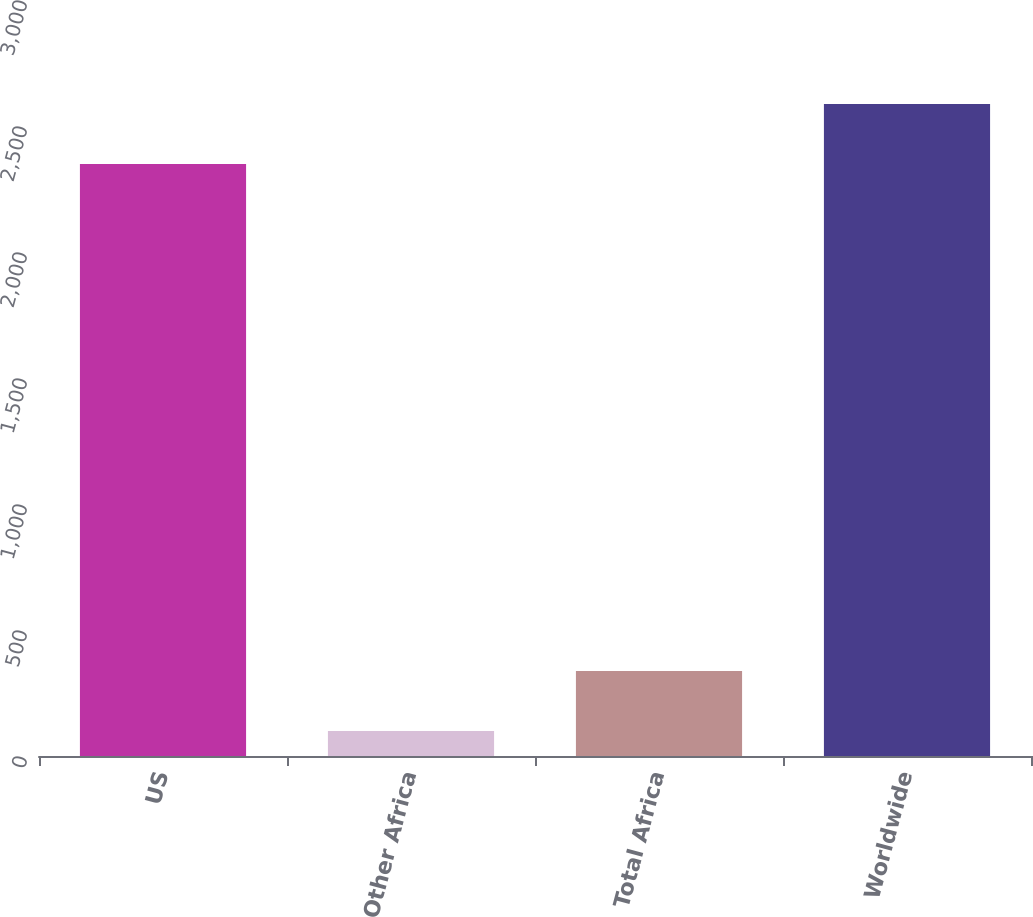Convert chart. <chart><loc_0><loc_0><loc_500><loc_500><bar_chart><fcel>US<fcel>Other Africa<fcel>Total Africa<fcel>Worldwide<nl><fcel>2349<fcel>99<fcel>336.9<fcel>2586.9<nl></chart> 